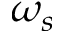<formula> <loc_0><loc_0><loc_500><loc_500>\omega _ { s }</formula> 